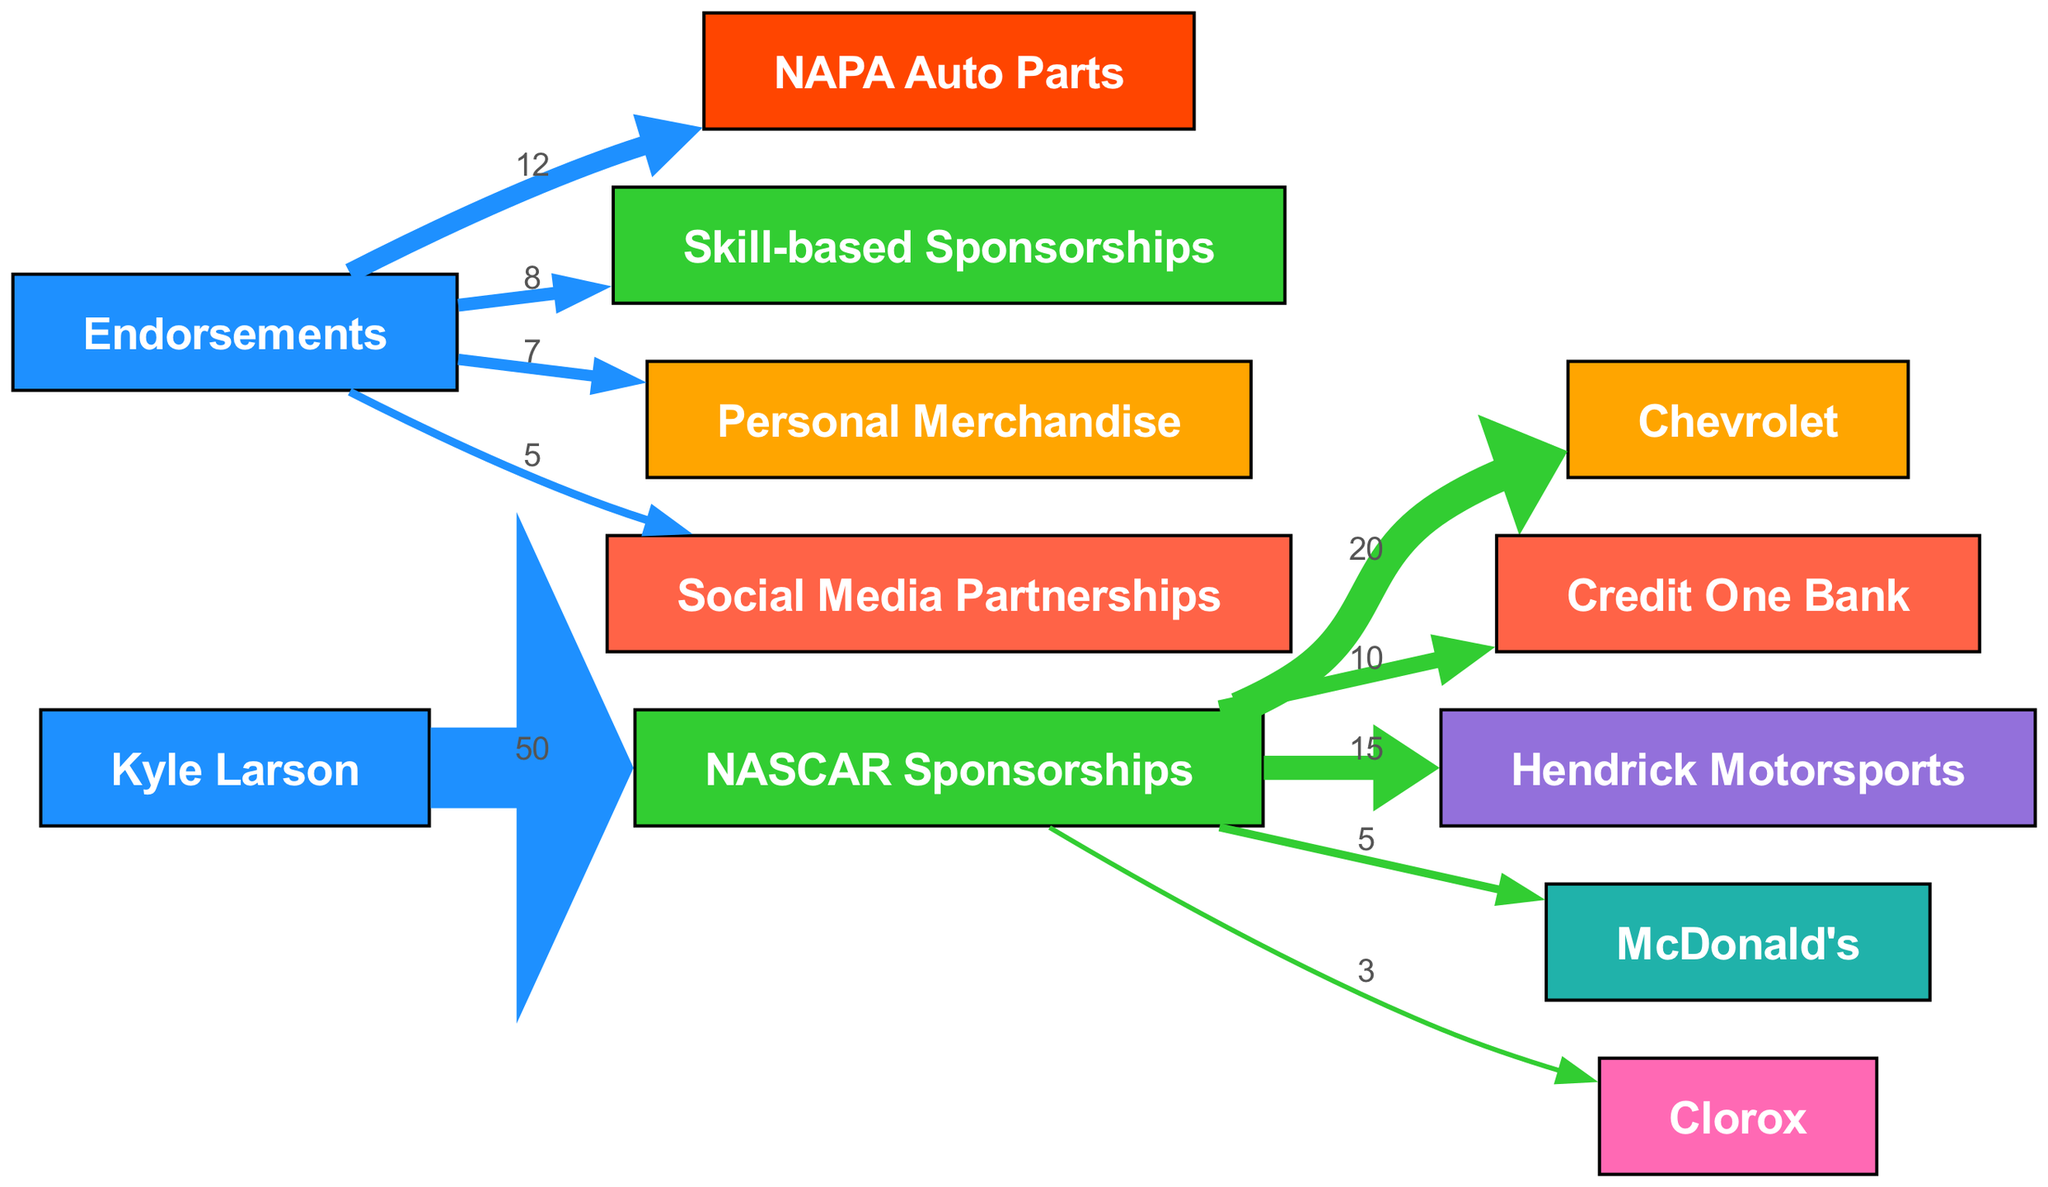What is the total sponsorship income from NASCAR Sponsorships? The diagram shows a direct connection from Kyle Larson to NASCAR Sponsorships with a value of 50, indicating that this is the total income from that category.
Answer: 50 Which sponsorship contributes the most to NASCAR Sponsorships? By examining the outgoing links from NASCAR Sponsorships, Chevrolet has the highest value of 20, indicating it contributes the most to the total.
Answer: Chevrolet How many endorsement sources are represented in the diagram? The endorsement section includes four different sources: NAPA Auto Parts, Skill-based Sponsorships, Personal Merchandise, and Social Media Partnerships, totaling four endorsement sources.
Answer: 4 What is the total income from the Endorsements category? Adding the outgoing values from the Endorsements node: 12 (NAPA Auto Parts) + 8 (Skill-based Sponsorships) + 7 (Personal Merchandise) + 5 (Social Media Partnerships) results in a total of 32 for Endorsements.
Answer: 32 Which node is directly connected to Kyle Larson with the highest flow value? The direct connections from Kyle Larson show that NASCAR Sponsorships has the highest flow value of 50, being the only link from him in the diagram.
Answer: NASCAR Sponsorships What percentage of NASCAR Sponsorships income comes from Hendrick Motorsports? The flow from NASCAR Sponsorships to Hendrick Motorsports is 15 out of a total 50, which is calculated as (15/50)*100 giving us 30%.
Answer: 30% Which endorsement has the least contribution to the overall income? Looking at the outgoing values from the Endorsements node, Social Media Partnerships has the lowest value of 5, meaning it has the least contribution in this section.
Answer: Social Media Partnerships What is the total value of connections coming from the Endorsements node? The connections from Endorsements total: 12 (NAPA Auto Parts) + 8 (Skill-based Sponsorships) + 7 (Personal Merchandise) + 5 (Social Media Partnerships) equals 32.
Answer: 32 What links out from NASCAR Sponsorships? The outgoing links from NASCAR Sponsorships are to Chevrolet, Credit One Bank, Hendrick Motorsports, McDonald's, and Clorox with respective values.
Answer: 5 links 